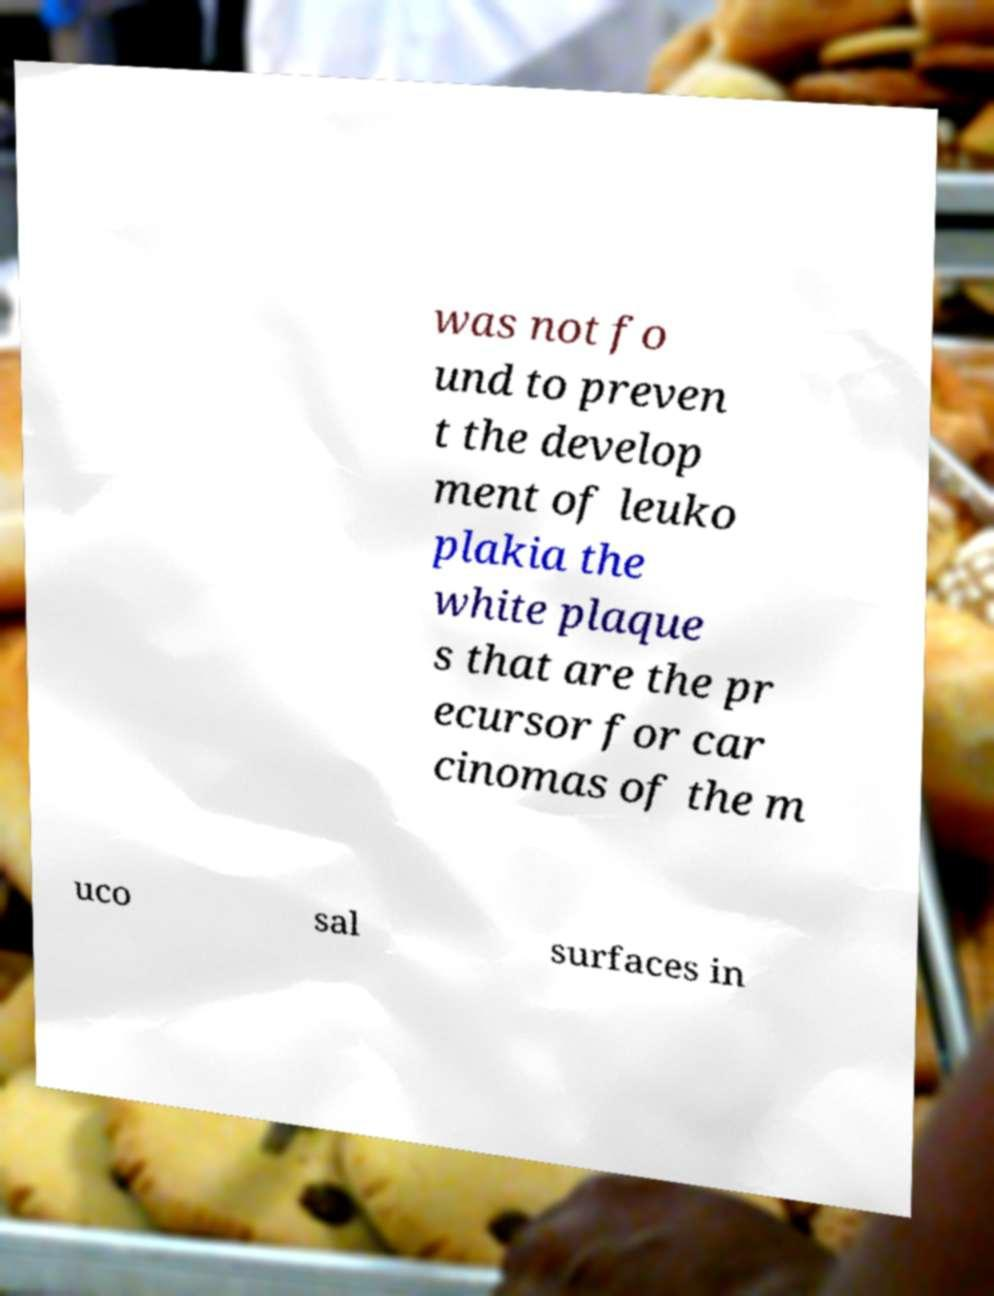Could you assist in decoding the text presented in this image and type it out clearly? was not fo und to preven t the develop ment of leuko plakia the white plaque s that are the pr ecursor for car cinomas of the m uco sal surfaces in 